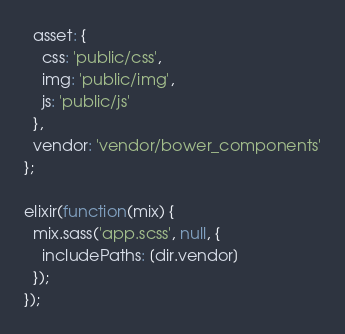<code> <loc_0><loc_0><loc_500><loc_500><_JavaScript_>  asset: {
    css: 'public/css',
    img: 'public/img',
    js: 'public/js'
  },
  vendor: 'vendor/bower_components'
};

elixir(function(mix) {
  mix.sass('app.scss', null, {
    includePaths: [dir.vendor]
  });
});
</code> 